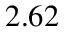Convert formula to latex. <formula><loc_0><loc_0><loc_500><loc_500>2 . 6 2</formula> 